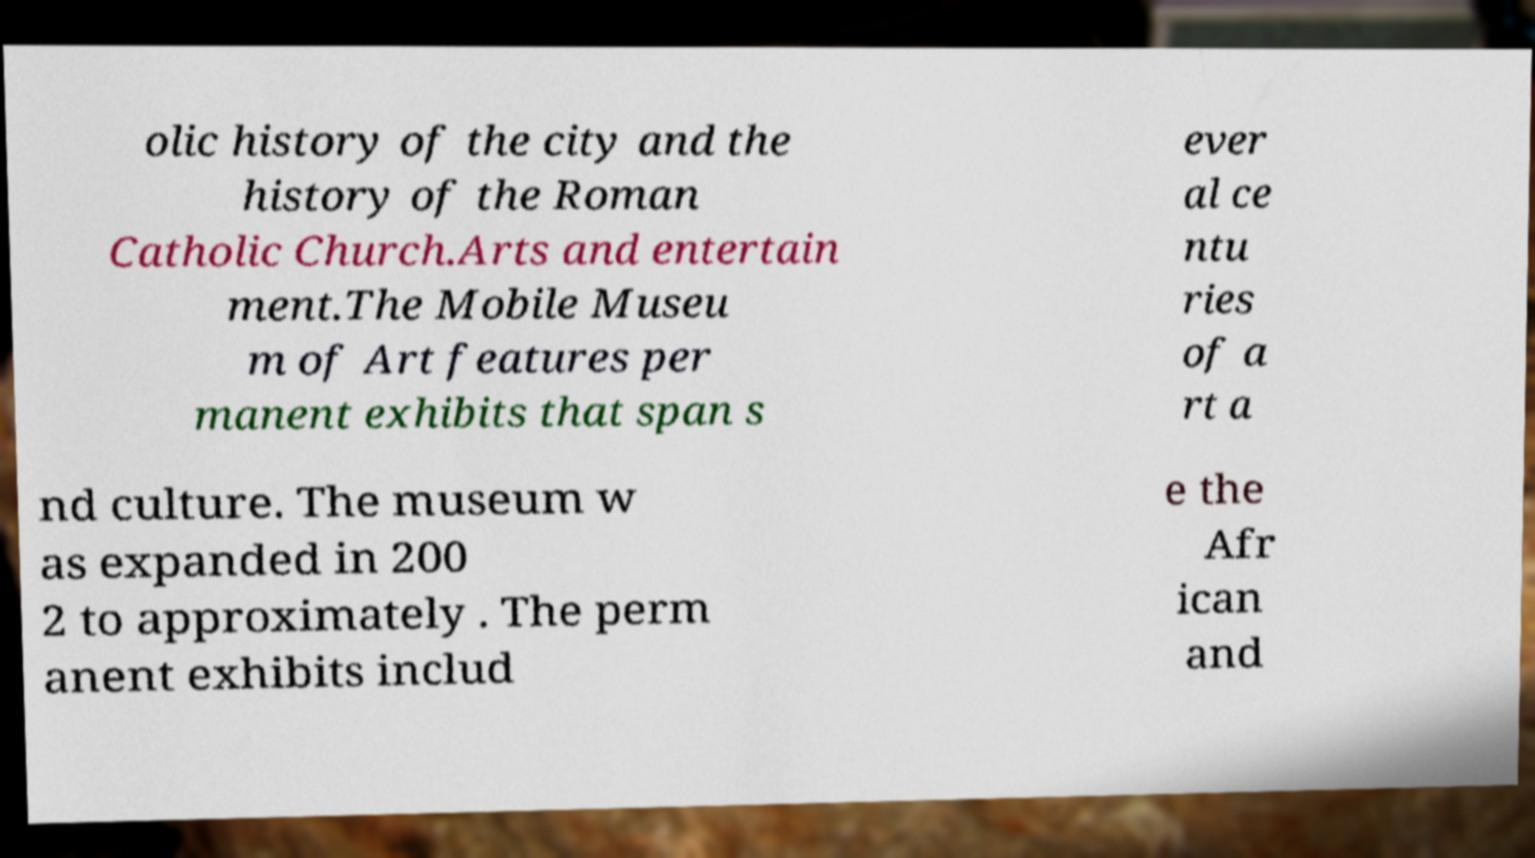Please identify and transcribe the text found in this image. olic history of the city and the history of the Roman Catholic Church.Arts and entertain ment.The Mobile Museu m of Art features per manent exhibits that span s ever al ce ntu ries of a rt a nd culture. The museum w as expanded in 200 2 to approximately . The perm anent exhibits includ e the Afr ican and 